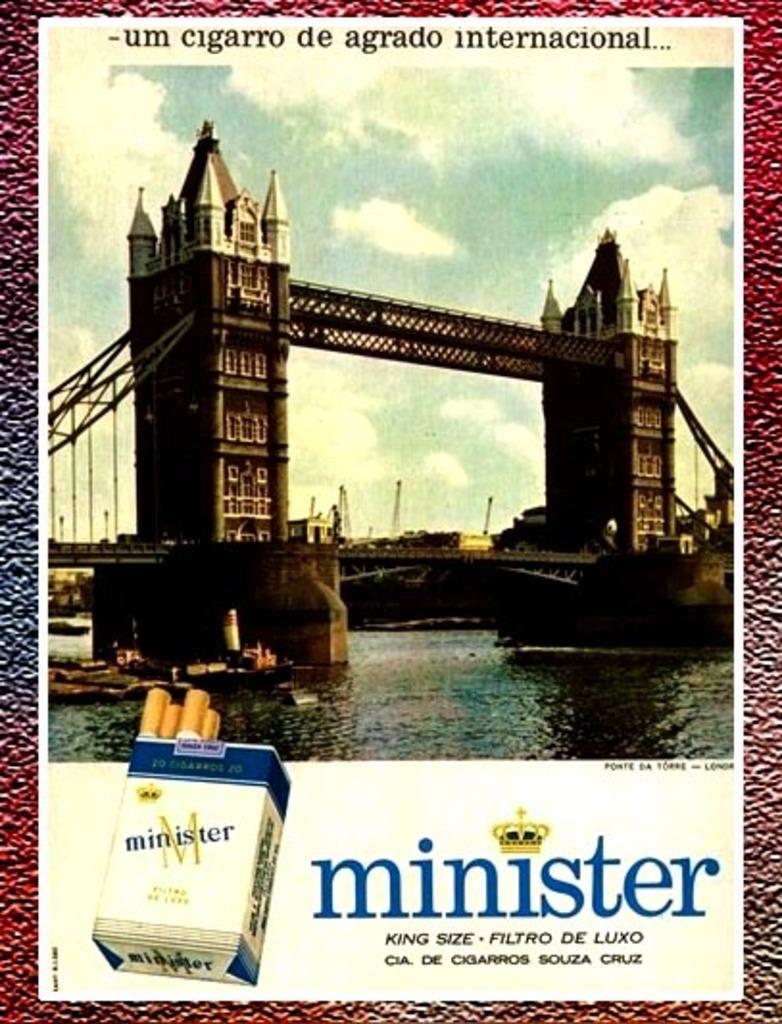<image>
Render a clear and concise summary of the photo. a picture of a bridge over water with a package of minister cigarettes 